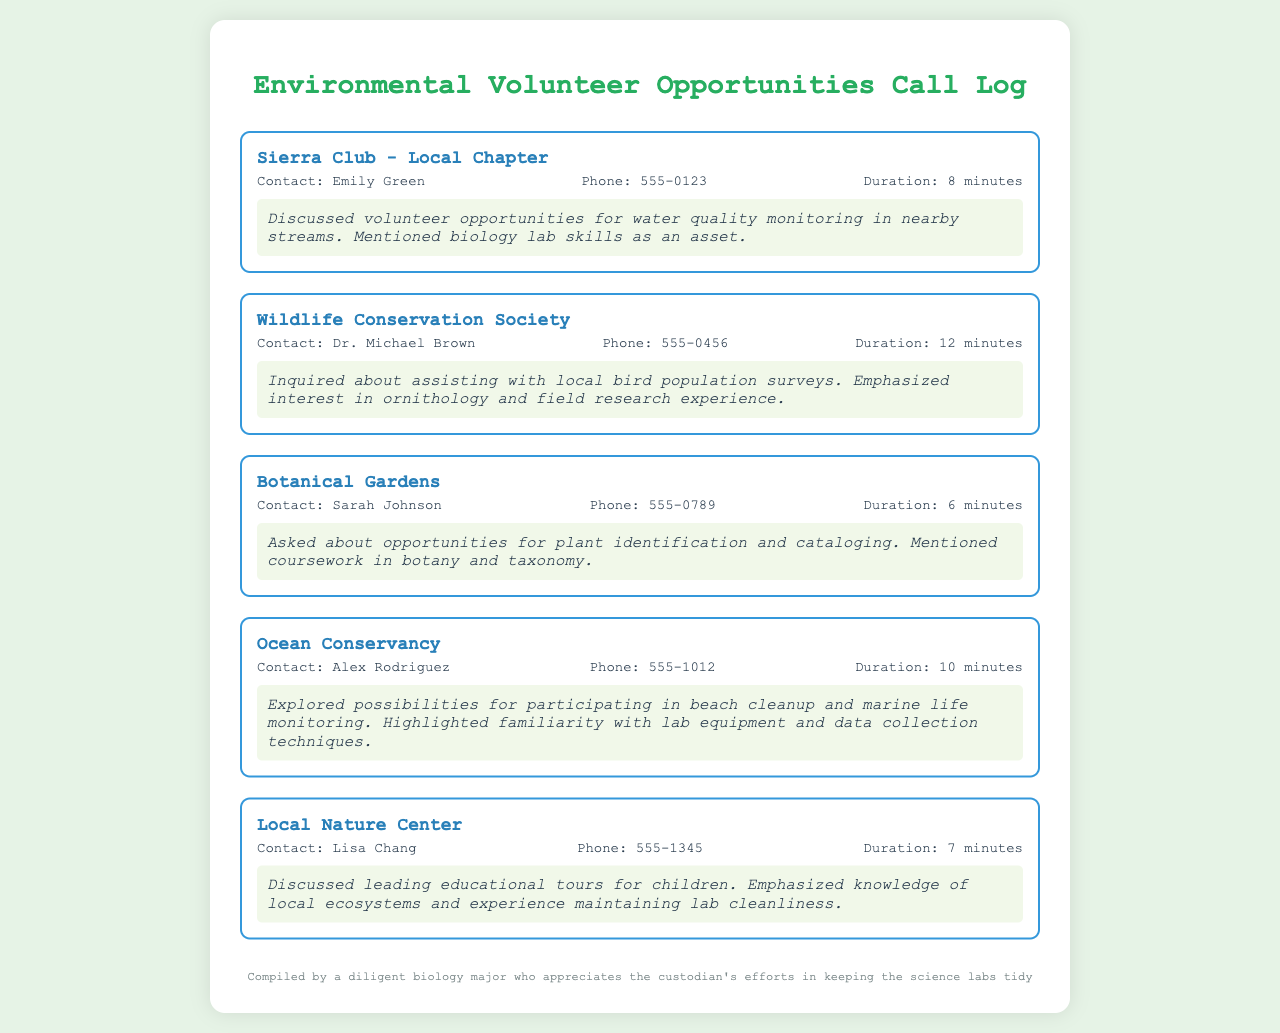What organization did you call to discuss water quality monitoring? The document lists the Sierra Club - Local Chapter as the organization discussed for water quality monitoring.
Answer: Sierra Club - Local Chapter Who was the contact person at the Wildlife Conservation Society? According to the document, the contact person for the Wildlife Conservation Society is Dr. Michael Brown.
Answer: Dr. Michael Brown How long was the call with the Botanical Gardens? The document states that the duration of the call with the Botanical Gardens was 6 minutes.
Answer: 6 minutes What specific volunteer opportunity was discussed with Ocean Conservancy? The document mentions participating in beach cleanup and marine life monitoring as the opportunity discussed with Ocean Conservancy.
Answer: Beach cleanup and marine life monitoring What skills were highlighted during the call with the Local Nature Center? According to the document, knowledge of local ecosystems and experience maintaining lab cleanliness were emphasized.
Answer: Knowledge of local ecosystems and experience maintaining lab cleanliness Which organization was contacted to explore bird population surveys? The document indicates that the call was made to the Wildlife Conservation Society to inquire about bird population surveys.
Answer: Wildlife Conservation Society How many minutes did the conversation with Alex Rodriguez last? The conversation with Alex Rodriguez lasted a total of 10 minutes as documented.
Answer: 10 minutes What opportunity did Sarah Johnson mention for volunteers? The document states that Sarah Johnson discussed opportunities for plant identification and cataloging.
Answer: Plant identification and cataloging What is the main focus of the conversations in this log? The main focus of the conversations in the log appears to be discussing volunteer opportunities for biology students.
Answer: Volunteer opportunities for biology students 